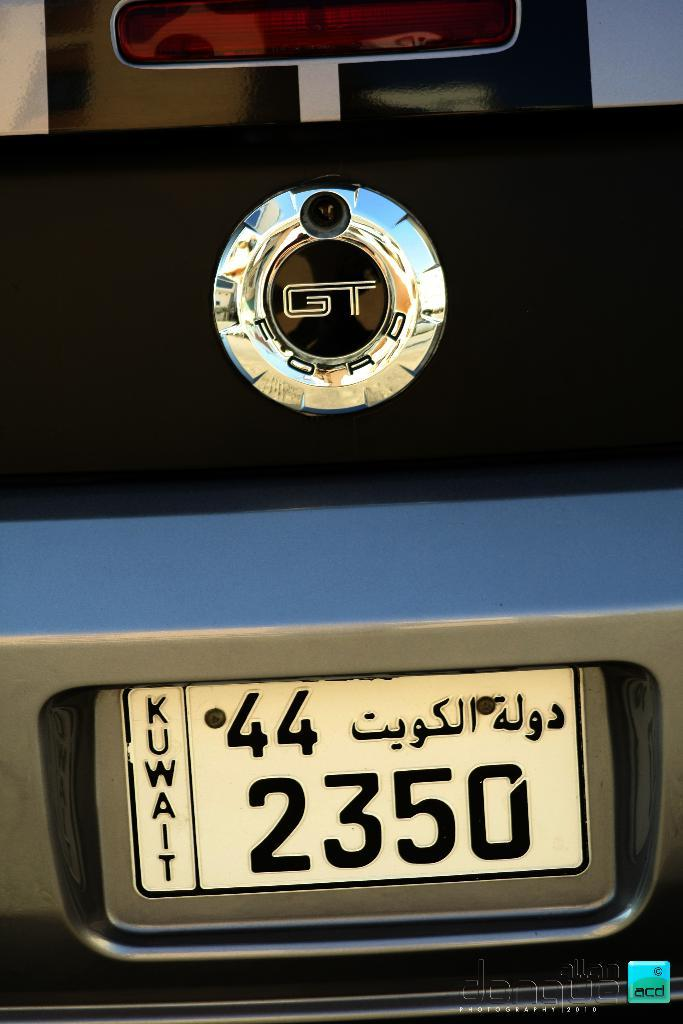What is the main focus of the image? The main focus of the image is a logo and a number plate of a car. Can you describe the logo in the image? Unfortunately, the description of the logo is not provided in the facts. What information can be found on the number plate of the car? The facts do not specify the details on the number plate. What type of acoustics can be heard coming from the cake in the image? There is no cake present in the image, so it's not possible to determine what, if any, acoustics might be heard. 